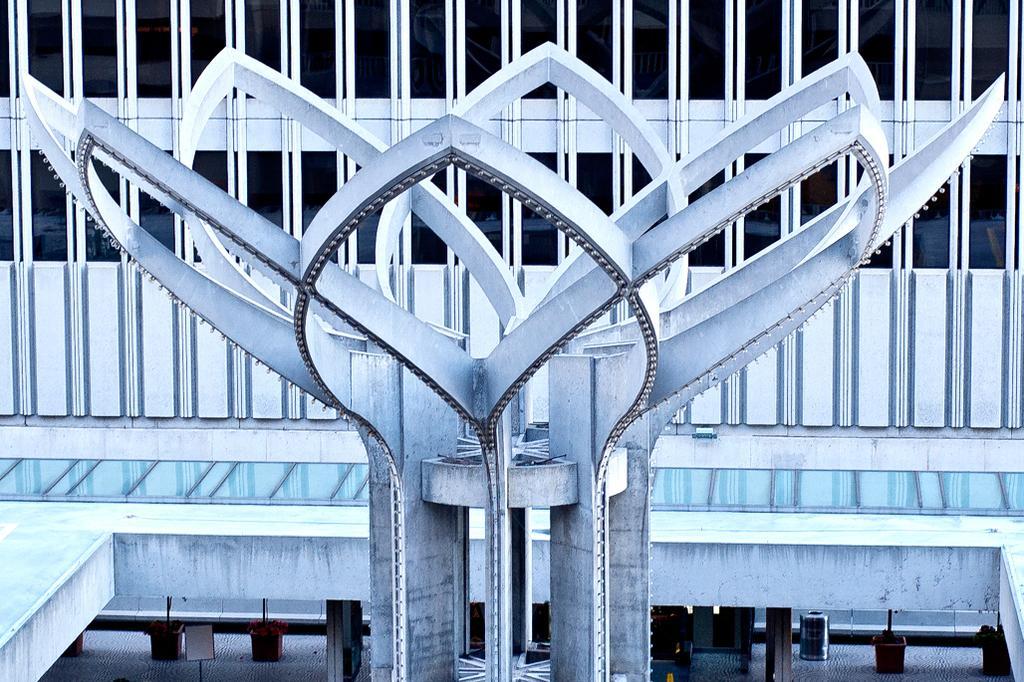Describe this image in one or two sentences. In the image I can see a sculpture which is in the shape of a flower and behind there are some grills. 